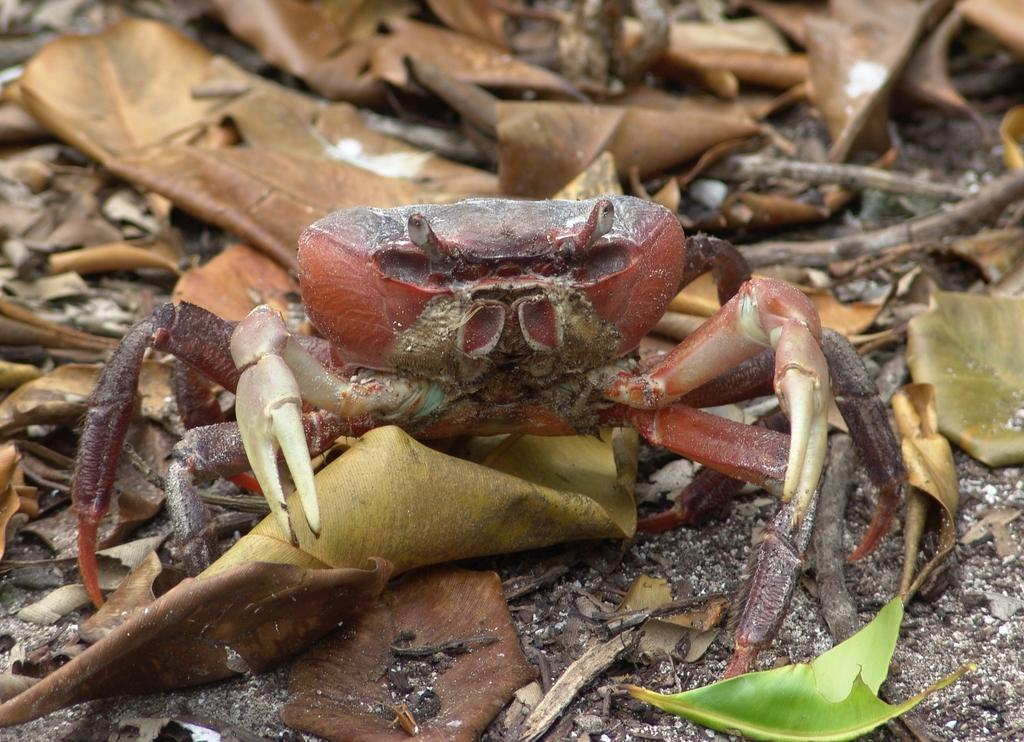What animal is on the ground in the image? There is a crab on the ground in the image. What type of vegetation can be seen in the image? There are leaves in the image. What other objects are present in the image? There are sticks in the image. What direction is the cushion facing in the image? There is no cushion present in the image. 